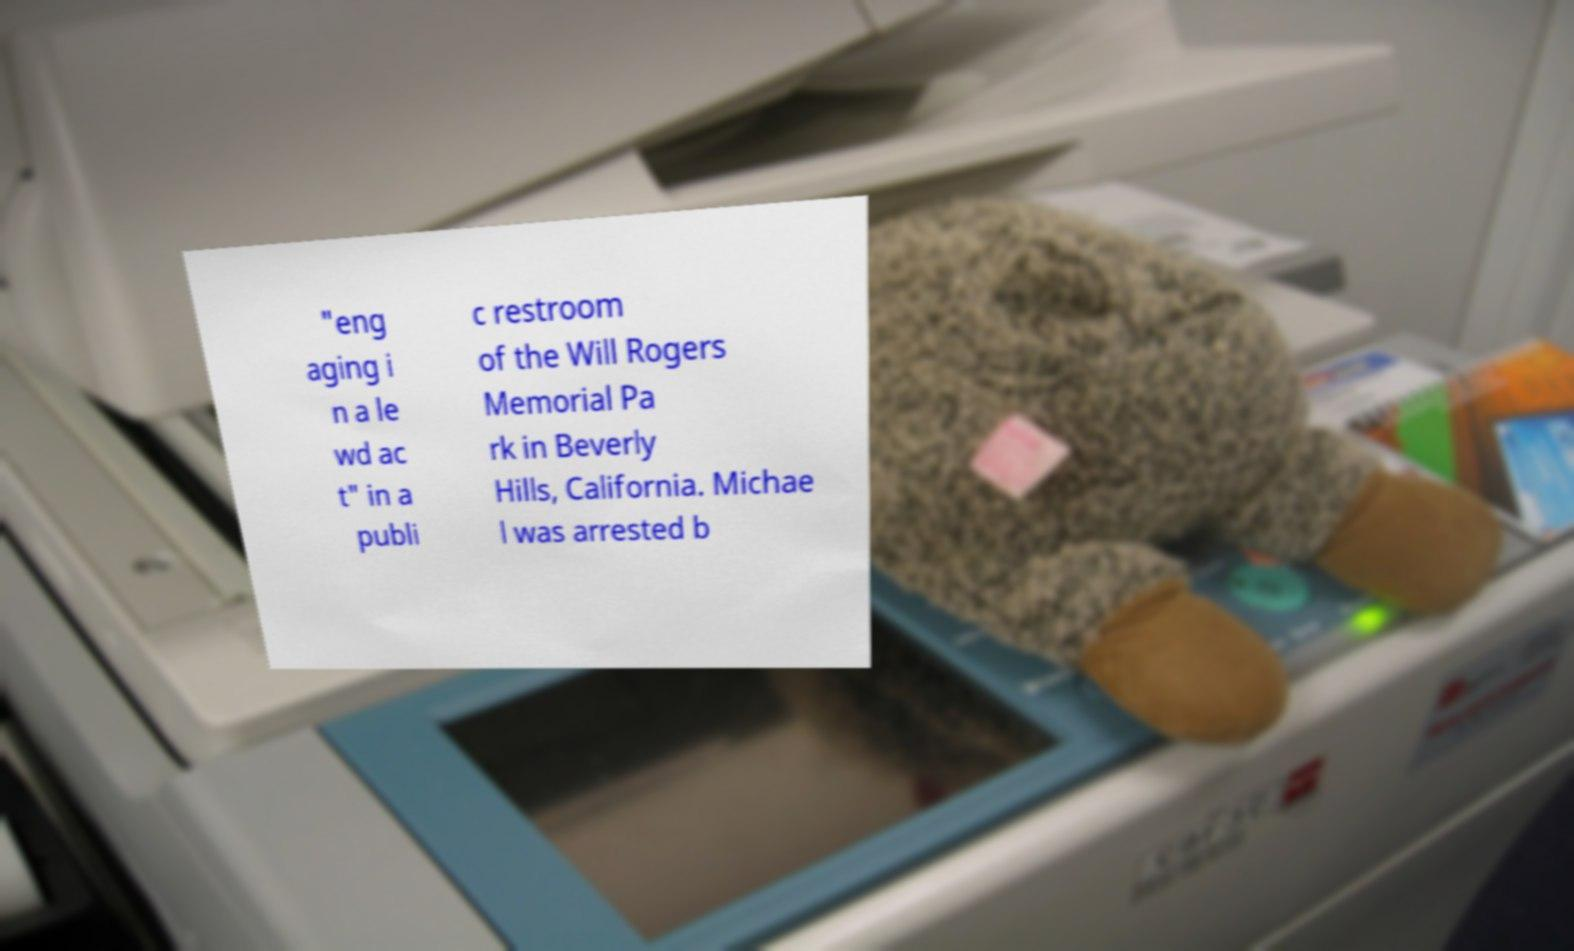There's text embedded in this image that I need extracted. Can you transcribe it verbatim? "eng aging i n a le wd ac t" in a publi c restroom of the Will Rogers Memorial Pa rk in Beverly Hills, California. Michae l was arrested b 